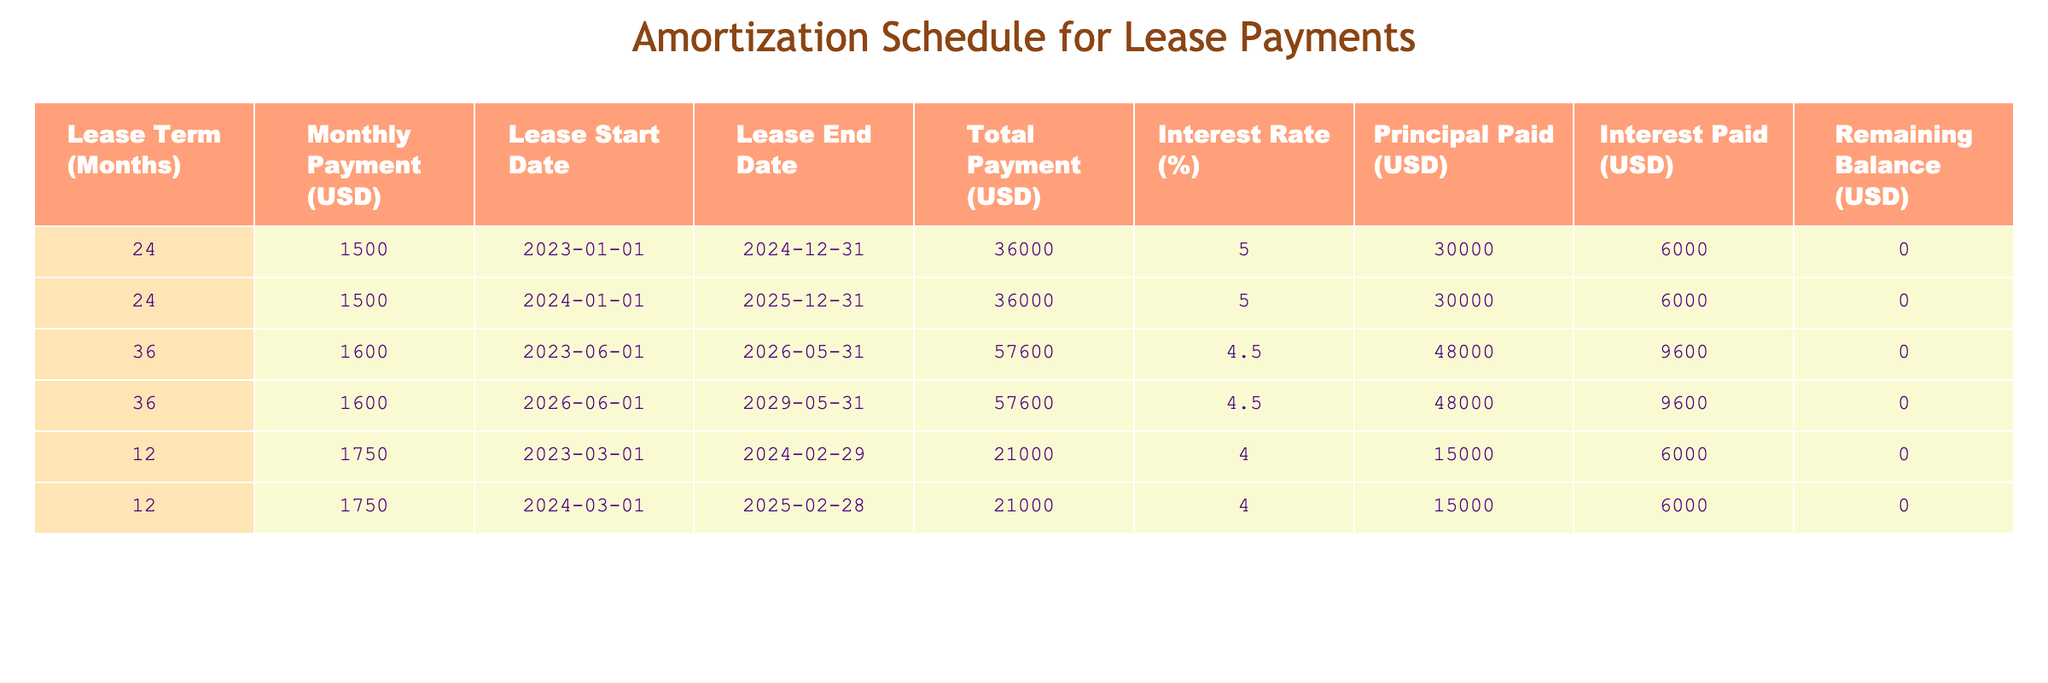What is the total payment for the lease starting on 2023-01-01? The total payment for the lease starting on 2023-01-01 is listed directly in the table under "Total Payment (USD)", which indicates 36000 USD for that lease.
Answer: 36000 USD How many months is the lease term for the studio space starting on 2024-01-01? The lease term for the studio space starting on 2024-01-01 is shown in the "Lease Term (Months)" column; it indicates a lease term of 24 months.
Answer: 24 months What is the combined principal paid for the leases that last for 36 months? To find the combined principal paid for the 36-month leases, I look at both entries for that duration. They each show 48000 USD as the principal paid, so adding them gives 48000 + 48000 = 96000 USD.
Answer: 96000 USD Is the interest rate the same for all leases in the table? By checking the "Interest Rate (%)" column, it becomes clear that not all leases have the same interest rate; some leases are at 5%, others at 4.5%, and others at 4%. Therefore, the statement is false.
Answer: No What is the remaining balance at the end of the lease term for the lease that starts on 2023-03-01? The remaining balance at the end of the lease term for the lease starting on 2023-03-01 is indicated in the "Remaining Balance (USD)" column, which shows 0 USD, meaning the lease term is completed without any remaining balance.
Answer: 0 USD What is the average monthly payment across all lease entries? To calculate the average monthly payment, I sum the monthly payments (1500 + 1500 + 1600 + 1600 + 1750 + 1750 = 10700 USD) and divide by the number of leases (6). Thus, 10700 / 6 = 1783.33 USD.
Answer: 1783.33 USD Which lease has the highest total payment and what is the amount? By comparing the total payment of each lease from the "Total Payment (USD)" column, the highest total payment is 57600 USD for the leases with a 36-month term starting on 2023-06-01 and 2026-06-01.
Answer: 57600 USD What is the difference between the total payments for the leases that last 12 months compared to those that last 24 months? First, I look at the total payments for the 12-month leases (21000 + 21000 = 42000 USD) and for the 24-month leases (36000 + 36000 = 72000 USD). The difference is 72000 - 42000 = 30000 USD.
Answer: 30000 USD Do both leases starting on 2023-01-01 and 2024-01-01 have the same principal paid? By checking the "Principal Paid (USD)" column, both leases indeed show the same amount of principal paid, which is 30000 USD for both leases. Thus, the statement is true.
Answer: Yes 